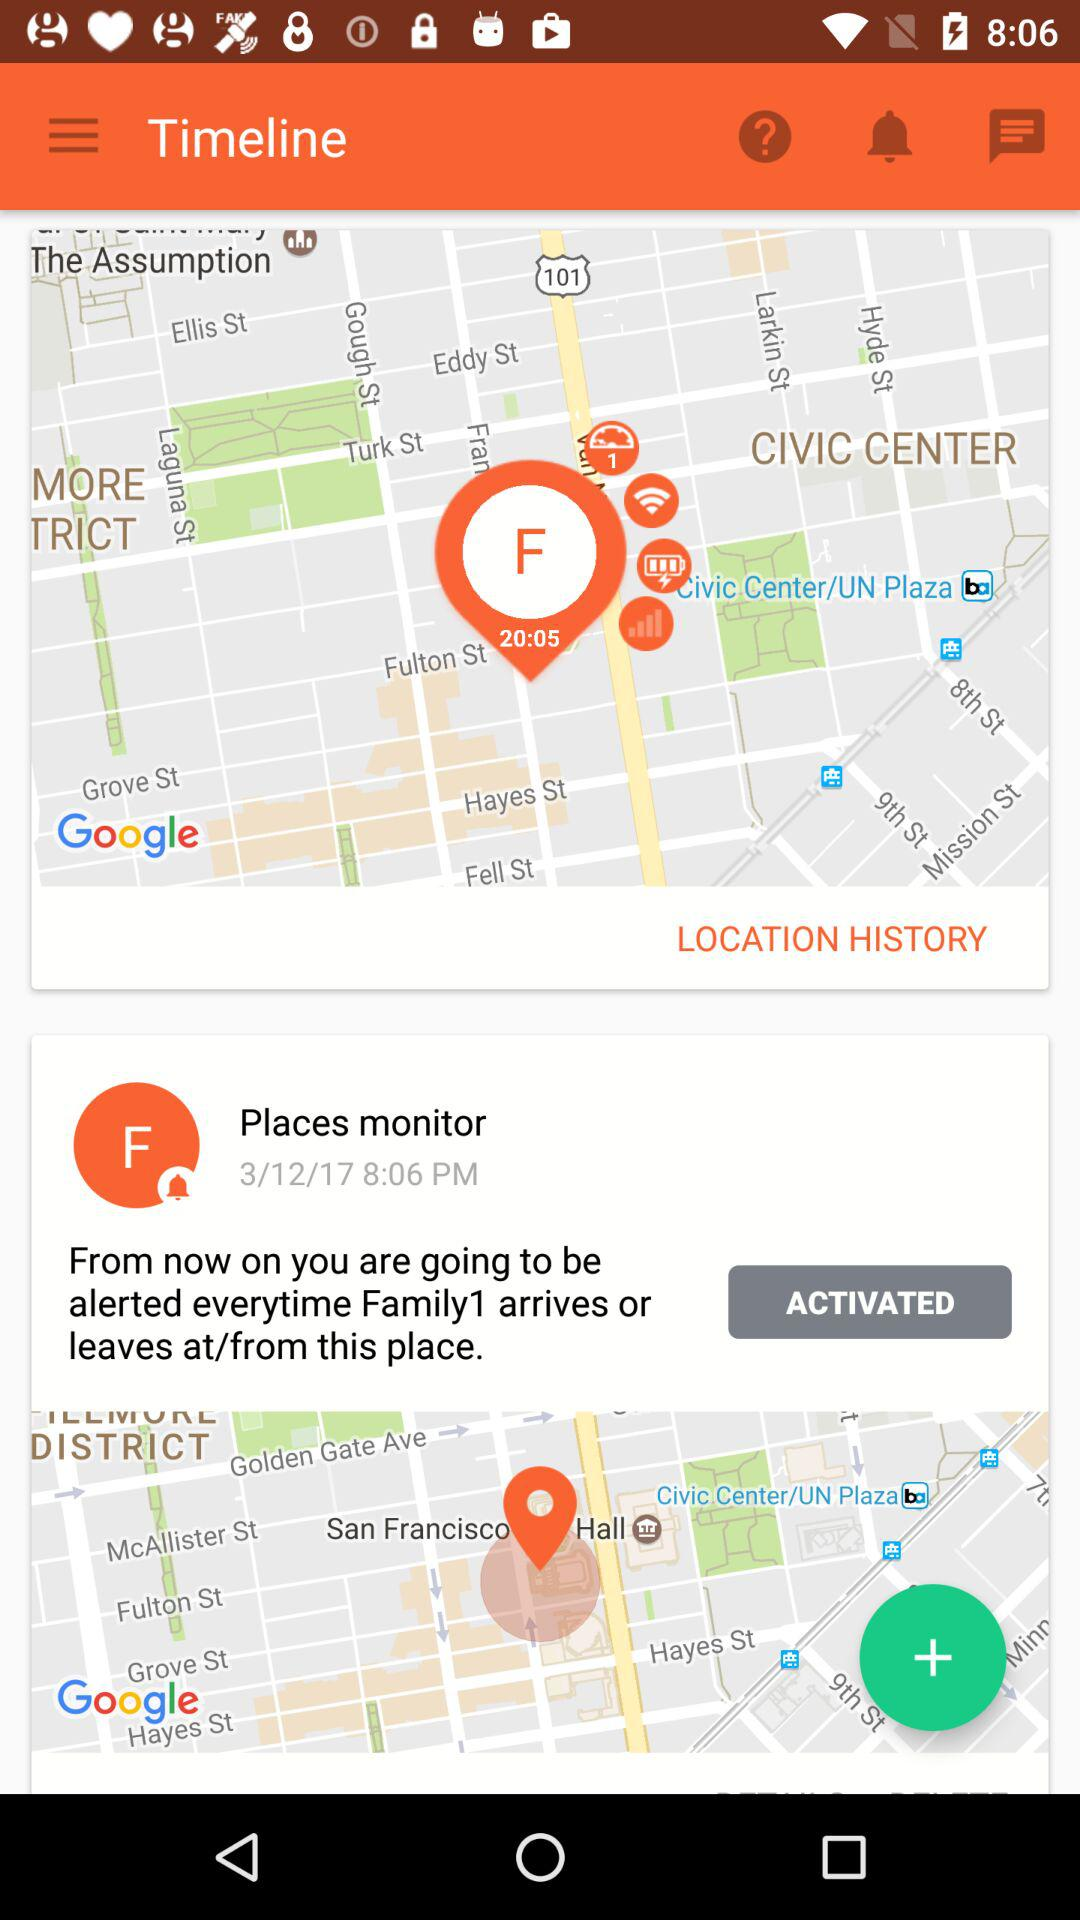How many places monitor does the user have?
Answer the question using a single word or phrase. 1 